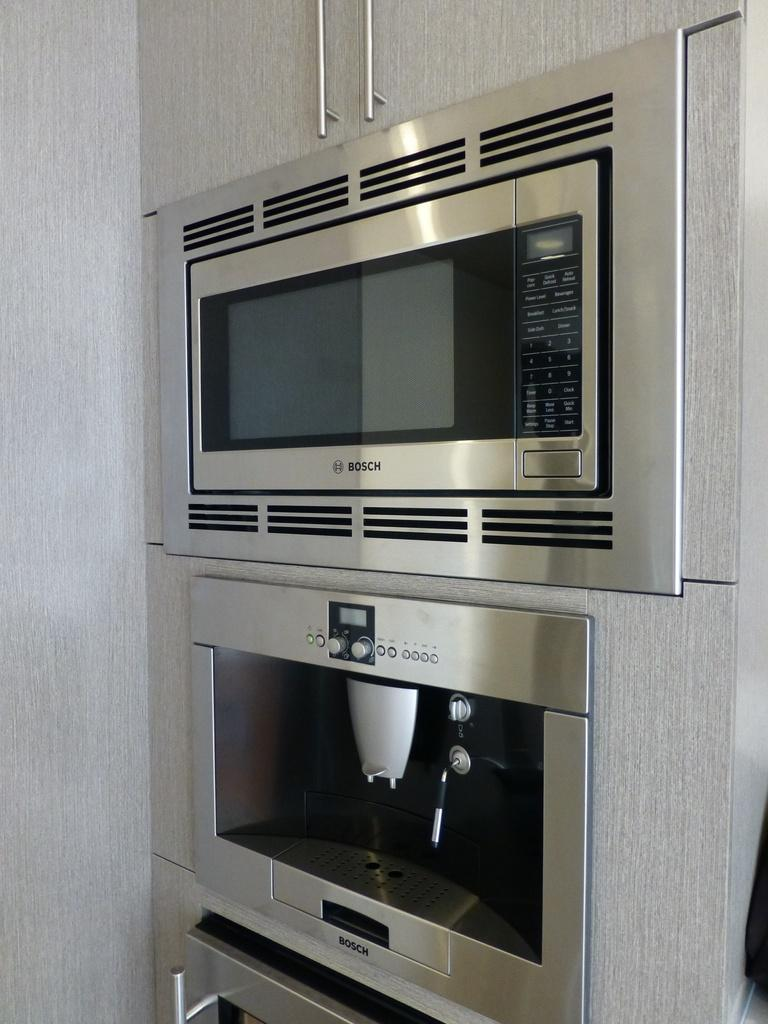<image>
Offer a succinct explanation of the picture presented. The very top appliance is a bosch microwave. 